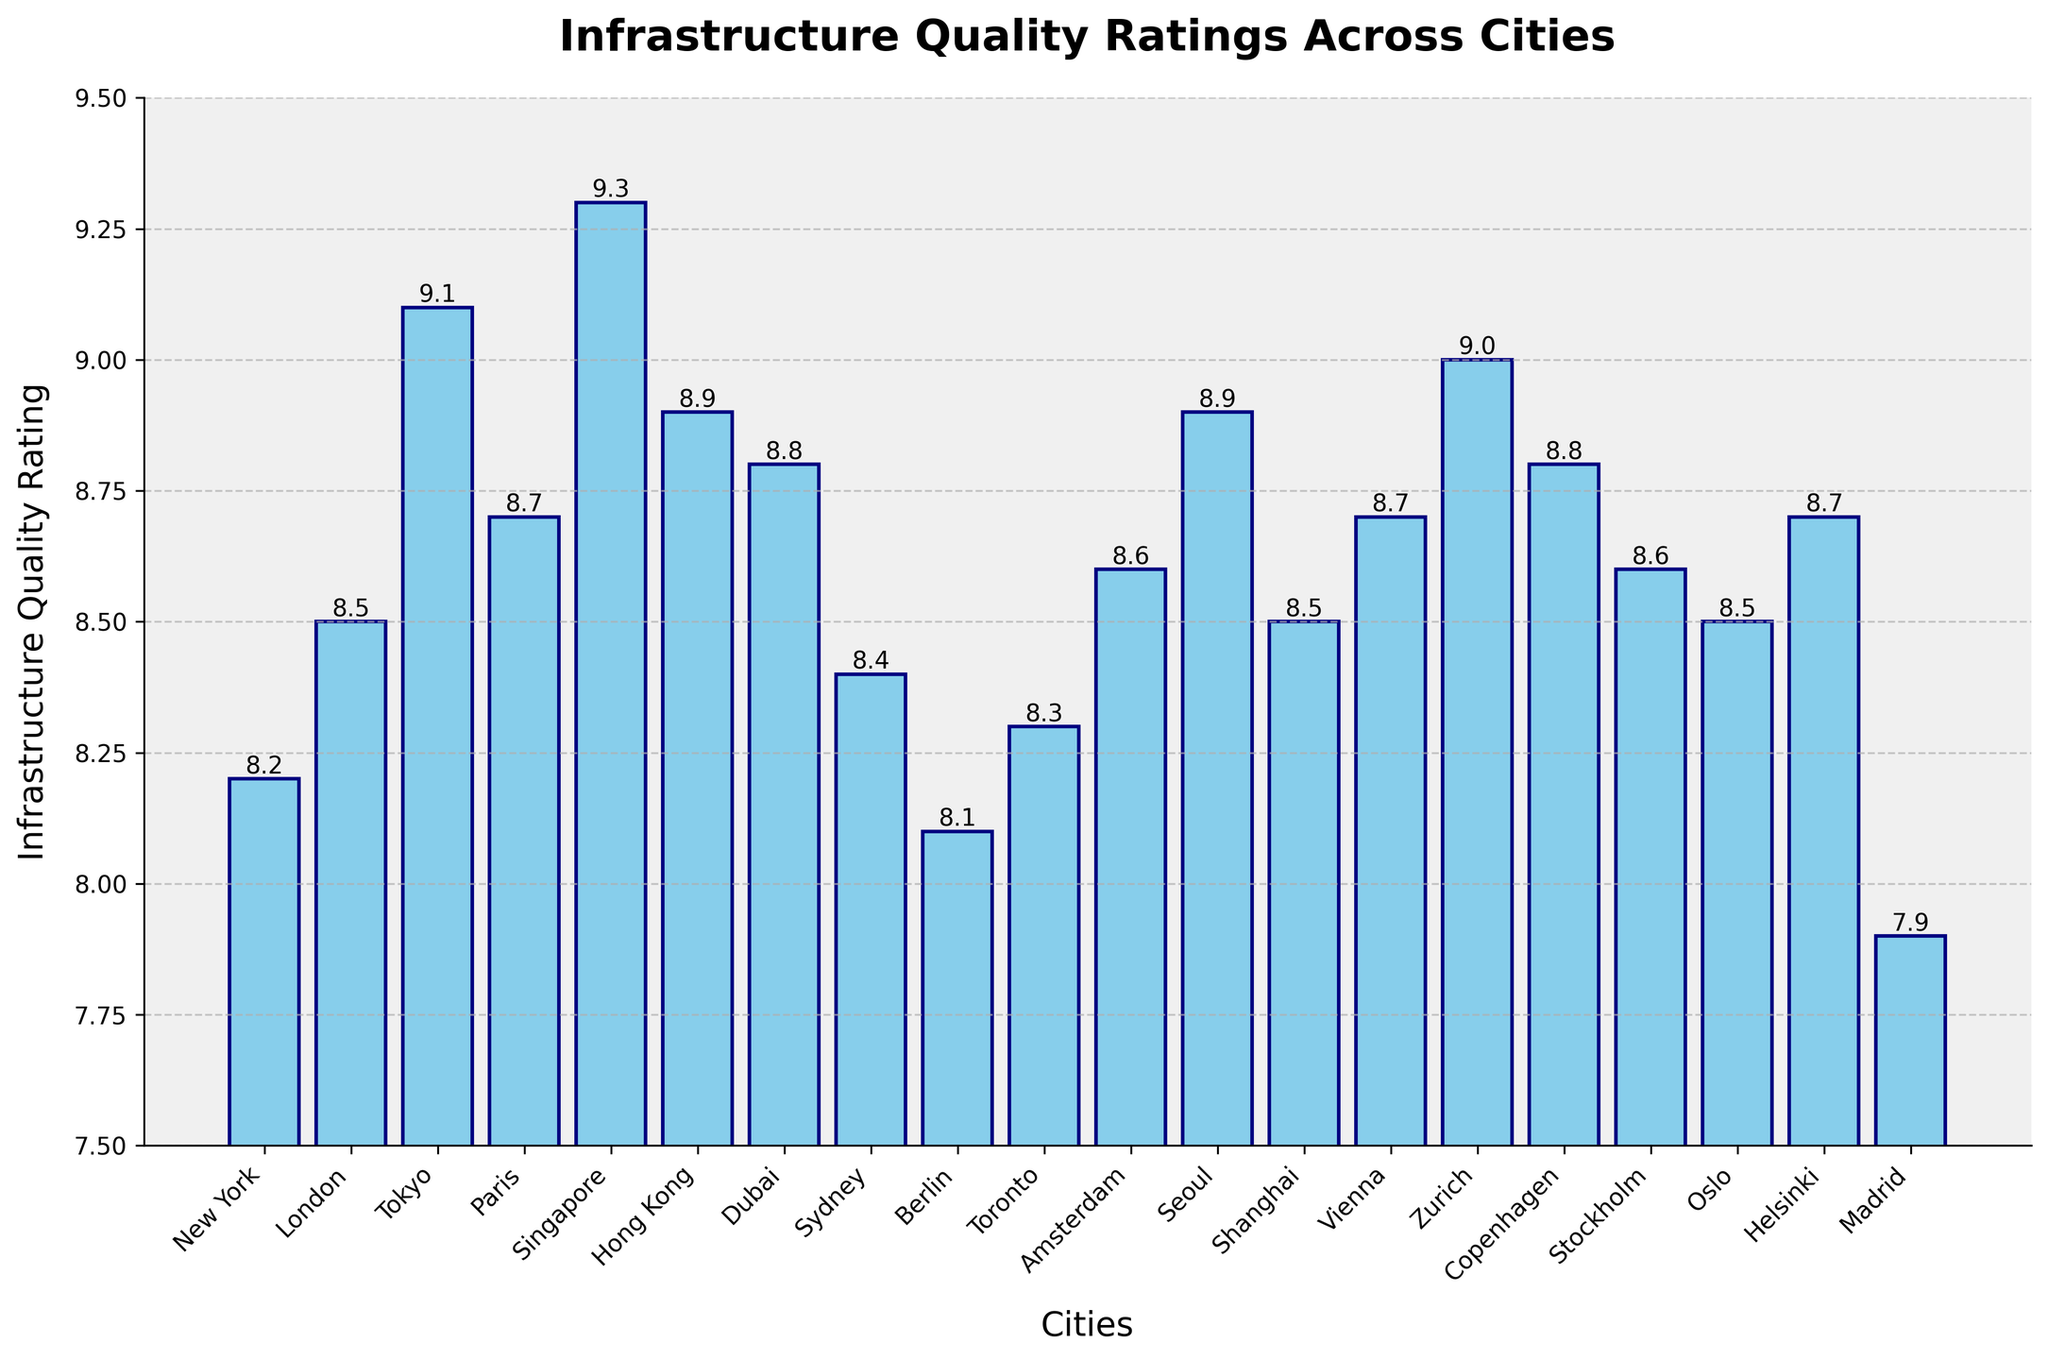What city has the highest infrastructure quality rating? Look at the bar with the greatest height and check its label. The tallest bar corresponds to Singapore.
Answer: Singapore Which cities have an infrastructure quality rating greater than 9? Identify the bars that extend beyond the 9 mark on the y-axis. These bars are Tokyo, Singapore, and Zurich.
Answer: Tokyo, Singapore, Zurich Which city has the lowest infrastructure quality rating? Find the bar with the shortest height and check its label, which corresponds to Madrid.
Answer: Madrid What is the difference in infrastructure quality rating between Tokyo and New York? Find the heights of the bars for Tokyo and New York, which are 9.1 and 8.2, respectively. Subtract the latter from the former: 9.1 - 8.2 = 0.9
Answer: 0.9 How many cities have an infrastructure quality rating less than 8.5? Identify the bars that do not extend beyond the 8.5 mark on the y-axis and count them. New York, Berlin, Toronto, Sydney, and Madrid fall into this category, totaling five cities.
Answer: 5 What is the average infrastructure quality rating of the cities in the chart? Add up the ratings of all the cities and divide by the number of cities. The sum of the ratings is \(8.2 + 8.5 + 9.1 + 8.7 + 9.3 + 8.9 + 8.8 + 8.4 + 8.1 + 8.3 + 8.6 + 8.9 + 8.5 + 8.7 + 9.0 + 8.8 + 8.6 + 8.5 + 8.7 + 7.9 = 169.6\). There are 20 cities, so the average rating is \(169.6 / 20 = 8.48\).
Answer: 8.48 Which cities have a rating equal to or above the value in Berlin? Berlin has a rating of 8.1. Any bar at the height of 8.1 or higher includes: New York, London, Tokyo, Paris, Singapore, Hong Kong, Dubai, Sydney, Toronto, Amsterdam, Seoul, Shanghai, Vienna, Zurich, Copenhagen, Stockholm, Oslo, Helsinki.
Answer: 18 cities What is the combined rating of the cities in the top 3 positions? The top 3 cities by ratings are Singapore (9.3), Tokyo (9.1), and Zurich (9.0). Add these values together: 9.3 + 9.1 + 9.0 = 27.4
Answer: 27.4 How does the rating for New York compare to that of Sydney? Compare the bar heights of New York and Sydney. New York has a rating of 8.2 while Sydney has 8.4. Thus, Sydney's rating is higher by 0.2.
Answer: Sydney higher by 0.2 How many cities have a rating exactly equal to 8.5? Look for bars that exactly fall on the 8.5 mark. London, Shanghai, Oslo all have this rating.
Answer: 3 